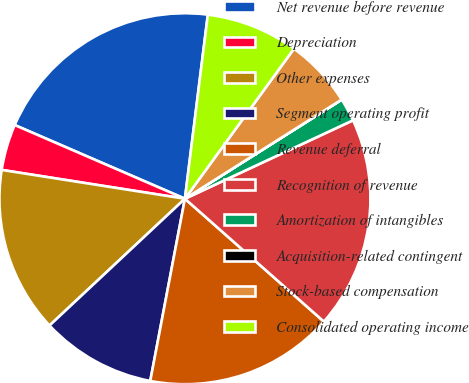<chart> <loc_0><loc_0><loc_500><loc_500><pie_chart><fcel>Net revenue before revenue<fcel>Depreciation<fcel>Other expenses<fcel>Segment operating profit<fcel>Revenue deferral<fcel>Recognition of revenue<fcel>Amortization of intangibles<fcel>Acquisition-related contingent<fcel>Stock-based compensation<fcel>Consolidated operating income<nl><fcel>20.47%<fcel>4.02%<fcel>14.46%<fcel>10.03%<fcel>16.47%<fcel>18.47%<fcel>2.02%<fcel>0.01%<fcel>6.02%<fcel>8.03%<nl></chart> 